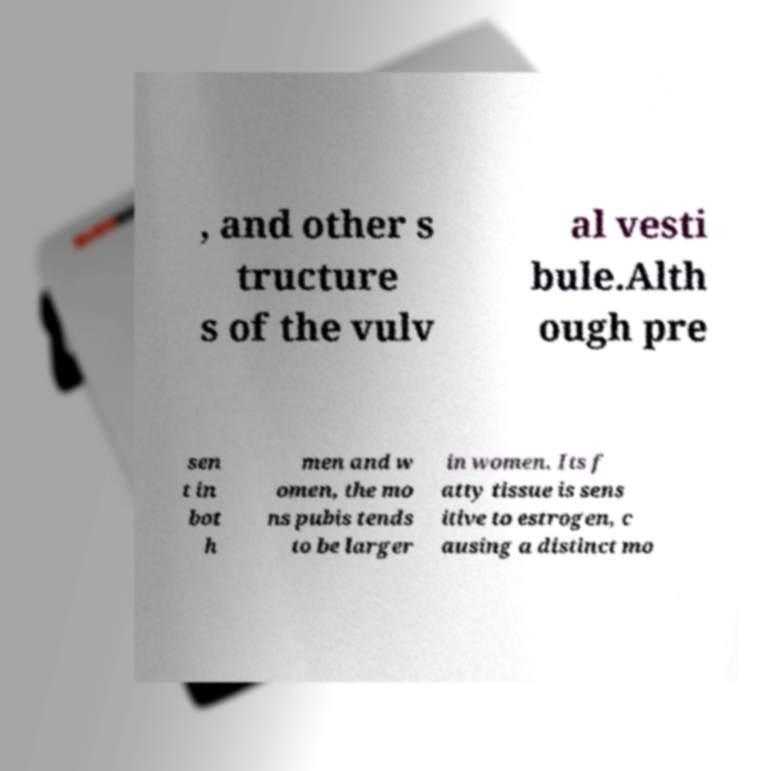Can you read and provide the text displayed in the image?This photo seems to have some interesting text. Can you extract and type it out for me? , and other s tructure s of the vulv al vesti bule.Alth ough pre sen t in bot h men and w omen, the mo ns pubis tends to be larger in women. Its f atty tissue is sens itive to estrogen, c ausing a distinct mo 